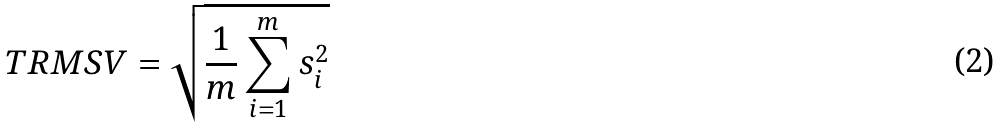Convert formula to latex. <formula><loc_0><loc_0><loc_500><loc_500>T R M S V = \sqrt { \frac { 1 } { m } \sum _ { i = 1 } ^ { m } s _ { i } ^ { 2 } }</formula> 